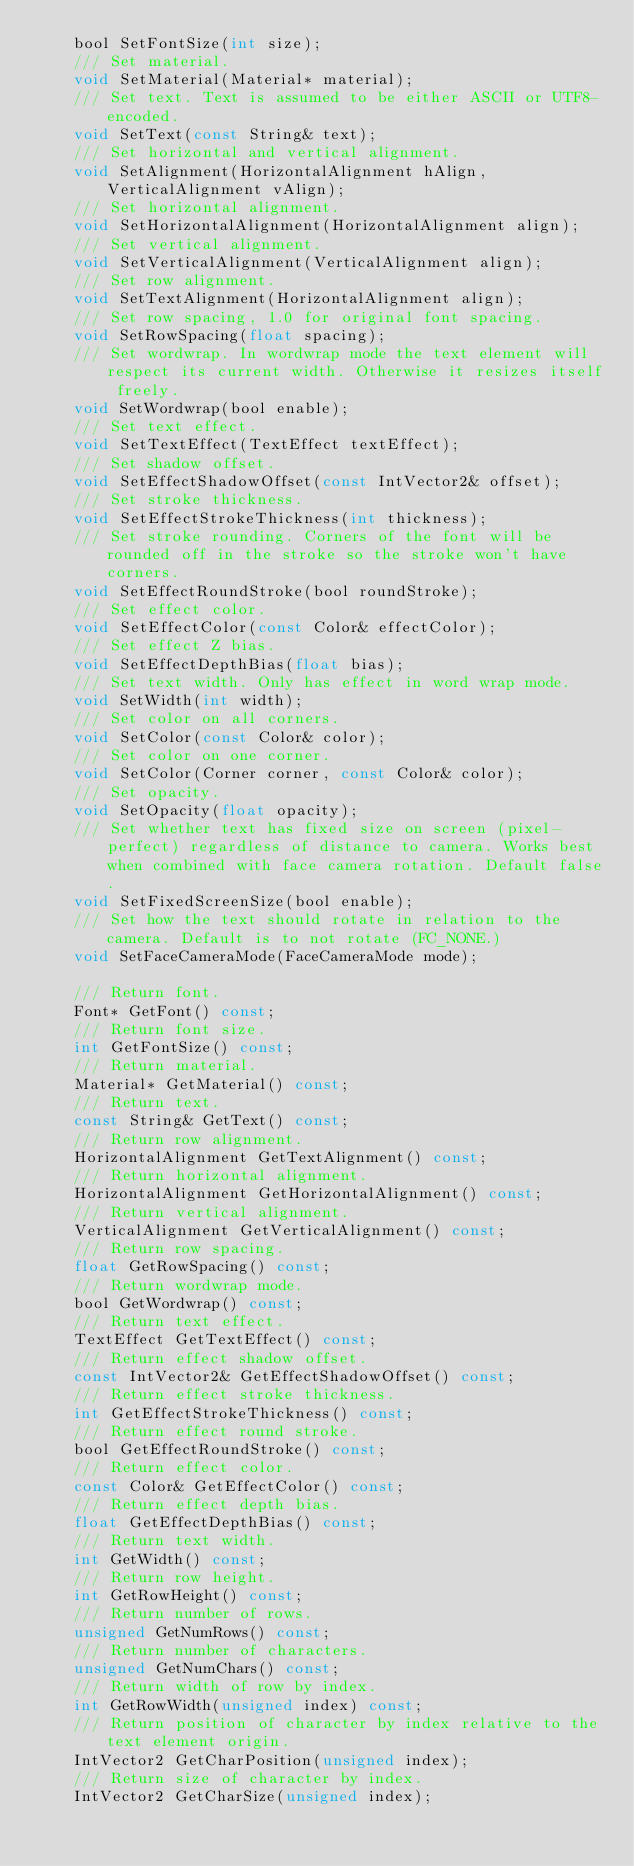Convert code to text. <code><loc_0><loc_0><loc_500><loc_500><_C_>    bool SetFontSize(int size);
    /// Set material.
    void SetMaterial(Material* material);
    /// Set text. Text is assumed to be either ASCII or UTF8-encoded.
    void SetText(const String& text);
    /// Set horizontal and vertical alignment.
    void SetAlignment(HorizontalAlignment hAlign, VerticalAlignment vAlign);
    /// Set horizontal alignment.
    void SetHorizontalAlignment(HorizontalAlignment align);
    /// Set vertical alignment.
    void SetVerticalAlignment(VerticalAlignment align);
    /// Set row alignment.
    void SetTextAlignment(HorizontalAlignment align);
    /// Set row spacing, 1.0 for original font spacing.
    void SetRowSpacing(float spacing);
    /// Set wordwrap. In wordwrap mode the text element will respect its current width. Otherwise it resizes itself freely.
    void SetWordwrap(bool enable);
    /// Set text effect.
    void SetTextEffect(TextEffect textEffect);
    /// Set shadow offset.
    void SetEffectShadowOffset(const IntVector2& offset);
    /// Set stroke thickness.
    void SetEffectStrokeThickness(int thickness);
    /// Set stroke rounding. Corners of the font will be rounded off in the stroke so the stroke won't have corners.
    void SetEffectRoundStroke(bool roundStroke);
    /// Set effect color.
    void SetEffectColor(const Color& effectColor);
    /// Set effect Z bias.
    void SetEffectDepthBias(float bias);
    /// Set text width. Only has effect in word wrap mode.
    void SetWidth(int width);
    /// Set color on all corners.
    void SetColor(const Color& color);
    /// Set color on one corner.
    void SetColor(Corner corner, const Color& color);
    /// Set opacity.
    void SetOpacity(float opacity);
    /// Set whether text has fixed size on screen (pixel-perfect) regardless of distance to camera. Works best when combined with face camera rotation. Default false.
    void SetFixedScreenSize(bool enable);
    /// Set how the text should rotate in relation to the camera. Default is to not rotate (FC_NONE.)
    void SetFaceCameraMode(FaceCameraMode mode);

    /// Return font.
    Font* GetFont() const;
    /// Return font size.
    int GetFontSize() const;
    /// Return material.
    Material* GetMaterial() const;
    /// Return text.
    const String& GetText() const;
    /// Return row alignment.
    HorizontalAlignment GetTextAlignment() const;
    /// Return horizontal alignment.
    HorizontalAlignment GetHorizontalAlignment() const;
    /// Return vertical alignment.
    VerticalAlignment GetVerticalAlignment() const;
    /// Return row spacing.
    float GetRowSpacing() const;
    /// Return wordwrap mode.
    bool GetWordwrap() const;
    /// Return text effect.
    TextEffect GetTextEffect() const;
    /// Return effect shadow offset.
    const IntVector2& GetEffectShadowOffset() const;
    /// Return effect stroke thickness.
    int GetEffectStrokeThickness() const;
    /// Return effect round stroke.
    bool GetEffectRoundStroke() const;
    /// Return effect color.
    const Color& GetEffectColor() const;
    /// Return effect depth bias.
    float GetEffectDepthBias() const;
    /// Return text width.
    int GetWidth() const;
    /// Return row height.
    int GetRowHeight() const;
    /// Return number of rows.
    unsigned GetNumRows() const;
    /// Return number of characters.
    unsigned GetNumChars() const;
    /// Return width of row by index.
    int GetRowWidth(unsigned index) const;
    /// Return position of character by index relative to the text element origin.
    IntVector2 GetCharPosition(unsigned index);
    /// Return size of character by index.
    IntVector2 GetCharSize(unsigned index);</code> 